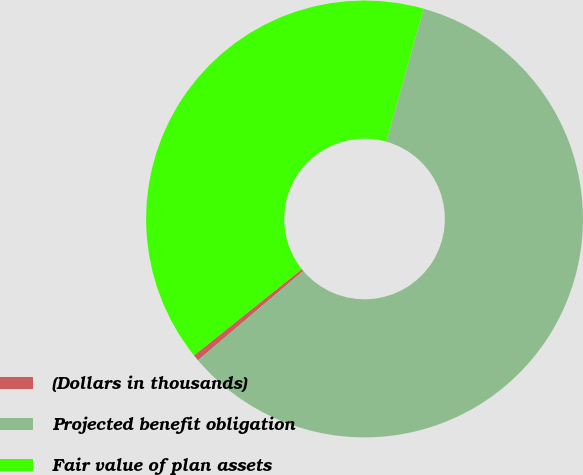Convert chart. <chart><loc_0><loc_0><loc_500><loc_500><pie_chart><fcel>(Dollars in thousands)<fcel>Projected benefit obligation<fcel>Fair value of plan assets<nl><fcel>0.47%<fcel>59.44%<fcel>40.09%<nl></chart> 